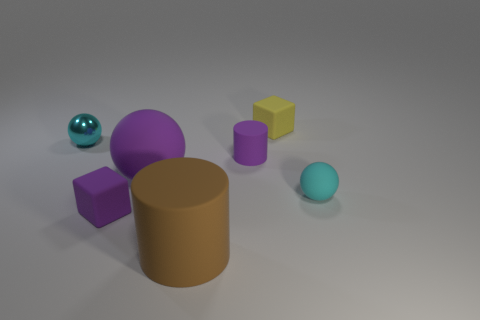Is the number of tiny cylinders right of the small yellow rubber cube greater than the number of purple cylinders left of the small metallic sphere?
Your answer should be compact. No. How many things are spheres behind the purple cylinder or large green objects?
Offer a very short reply. 1. There is a brown thing that is made of the same material as the purple sphere; what shape is it?
Make the answer very short. Cylinder. Are there any other things that are the same shape as the tiny shiny thing?
Offer a very short reply. Yes. What is the color of the tiny object that is on the left side of the small rubber cylinder and behind the purple cylinder?
Make the answer very short. Cyan. What number of cylinders are either green objects or big things?
Offer a terse response. 1. How many cylinders have the same size as the shiny thing?
Make the answer very short. 1. What number of yellow objects are in front of the small purple rubber object that is on the right side of the brown cylinder?
Provide a succinct answer. 0. There is a thing that is both in front of the cyan rubber sphere and behind the brown matte cylinder; what is its size?
Your response must be concise. Small. Are there more purple cylinders than large metallic cylinders?
Ensure brevity in your answer.  Yes. 